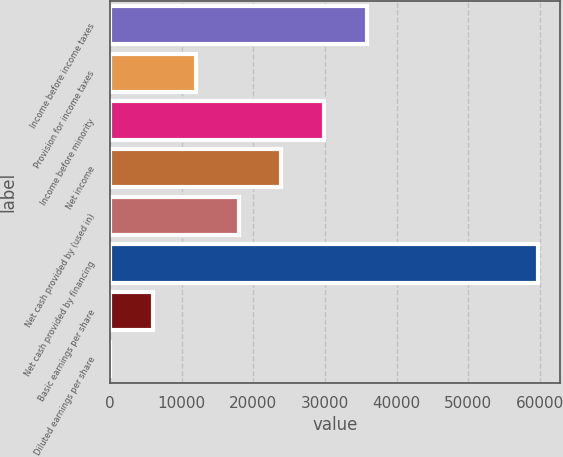Convert chart to OTSL. <chart><loc_0><loc_0><loc_500><loc_500><bar_chart><fcel>Income before income taxes<fcel>Provision for income taxes<fcel>Income before minority<fcel>Net income<fcel>Net cash provided by (used in)<fcel>Net cash provided by financing<fcel>Basic earnings per share<fcel>Diluted earnings per share<nl><fcel>35876.1<fcel>11962.3<fcel>29897.7<fcel>23919.2<fcel>17940.7<fcel>59790<fcel>5983.82<fcel>5.36<nl></chart> 